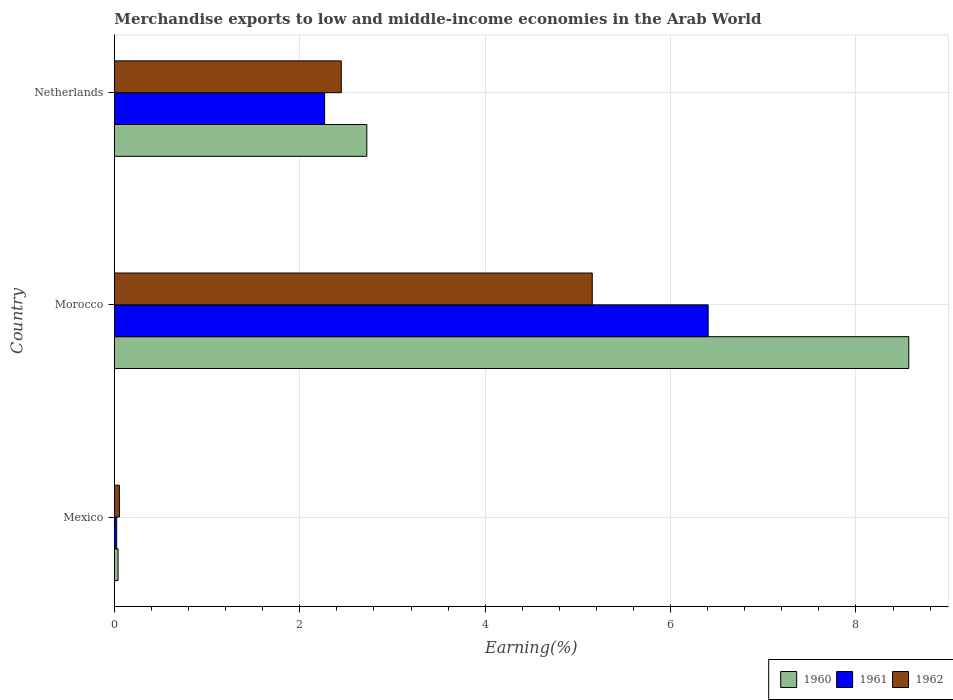How many groups of bars are there?
Your answer should be very brief. 3. Are the number of bars per tick equal to the number of legend labels?
Your answer should be compact. Yes. How many bars are there on the 2nd tick from the top?
Provide a short and direct response. 3. How many bars are there on the 1st tick from the bottom?
Provide a short and direct response. 3. What is the percentage of amount earned from merchandise exports in 1960 in Netherlands?
Offer a terse response. 2.72. Across all countries, what is the maximum percentage of amount earned from merchandise exports in 1961?
Keep it short and to the point. 6.41. Across all countries, what is the minimum percentage of amount earned from merchandise exports in 1960?
Keep it short and to the point. 0.04. In which country was the percentage of amount earned from merchandise exports in 1960 maximum?
Provide a short and direct response. Morocco. What is the total percentage of amount earned from merchandise exports in 1962 in the graph?
Offer a very short reply. 7.66. What is the difference between the percentage of amount earned from merchandise exports in 1962 in Mexico and that in Netherlands?
Make the answer very short. -2.39. What is the difference between the percentage of amount earned from merchandise exports in 1961 in Netherlands and the percentage of amount earned from merchandise exports in 1960 in Mexico?
Your answer should be very brief. 2.23. What is the average percentage of amount earned from merchandise exports in 1960 per country?
Keep it short and to the point. 3.78. What is the difference between the percentage of amount earned from merchandise exports in 1960 and percentage of amount earned from merchandise exports in 1961 in Netherlands?
Make the answer very short. 0.46. What is the ratio of the percentage of amount earned from merchandise exports in 1960 in Mexico to that in Morocco?
Your response must be concise. 0. What is the difference between the highest and the second highest percentage of amount earned from merchandise exports in 1961?
Provide a short and direct response. 4.14. What is the difference between the highest and the lowest percentage of amount earned from merchandise exports in 1961?
Your answer should be very brief. 6.38. In how many countries, is the percentage of amount earned from merchandise exports in 1961 greater than the average percentage of amount earned from merchandise exports in 1961 taken over all countries?
Offer a terse response. 1. Is the sum of the percentage of amount earned from merchandise exports in 1960 in Mexico and Morocco greater than the maximum percentage of amount earned from merchandise exports in 1961 across all countries?
Your answer should be compact. Yes. How many bars are there?
Provide a short and direct response. 9. How many countries are there in the graph?
Your response must be concise. 3. What is the difference between two consecutive major ticks on the X-axis?
Provide a succinct answer. 2. Are the values on the major ticks of X-axis written in scientific E-notation?
Ensure brevity in your answer.  No. Does the graph contain grids?
Ensure brevity in your answer.  Yes. How many legend labels are there?
Provide a short and direct response. 3. What is the title of the graph?
Offer a terse response. Merchandise exports to low and middle-income economies in the Arab World. What is the label or title of the X-axis?
Make the answer very short. Earning(%). What is the label or title of the Y-axis?
Offer a terse response. Country. What is the Earning(%) in 1960 in Mexico?
Offer a terse response. 0.04. What is the Earning(%) in 1961 in Mexico?
Provide a short and direct response. 0.02. What is the Earning(%) in 1962 in Mexico?
Your answer should be compact. 0.05. What is the Earning(%) in 1960 in Morocco?
Your answer should be compact. 8.57. What is the Earning(%) of 1961 in Morocco?
Provide a succinct answer. 6.41. What is the Earning(%) in 1962 in Morocco?
Give a very brief answer. 5.15. What is the Earning(%) of 1960 in Netherlands?
Your answer should be very brief. 2.72. What is the Earning(%) in 1961 in Netherlands?
Provide a short and direct response. 2.27. What is the Earning(%) of 1962 in Netherlands?
Ensure brevity in your answer.  2.45. Across all countries, what is the maximum Earning(%) of 1960?
Offer a very short reply. 8.57. Across all countries, what is the maximum Earning(%) in 1961?
Your answer should be very brief. 6.41. Across all countries, what is the maximum Earning(%) of 1962?
Provide a succinct answer. 5.15. Across all countries, what is the minimum Earning(%) of 1960?
Your answer should be very brief. 0.04. Across all countries, what is the minimum Earning(%) of 1961?
Your response must be concise. 0.02. Across all countries, what is the minimum Earning(%) of 1962?
Keep it short and to the point. 0.05. What is the total Earning(%) in 1960 in the graph?
Provide a short and direct response. 11.33. What is the total Earning(%) in 1961 in the graph?
Your response must be concise. 8.7. What is the total Earning(%) of 1962 in the graph?
Make the answer very short. 7.66. What is the difference between the Earning(%) of 1960 in Mexico and that in Morocco?
Ensure brevity in your answer.  -8.53. What is the difference between the Earning(%) of 1961 in Mexico and that in Morocco?
Keep it short and to the point. -6.38. What is the difference between the Earning(%) in 1962 in Mexico and that in Morocco?
Offer a very short reply. -5.1. What is the difference between the Earning(%) in 1960 in Mexico and that in Netherlands?
Keep it short and to the point. -2.68. What is the difference between the Earning(%) in 1961 in Mexico and that in Netherlands?
Offer a terse response. -2.24. What is the difference between the Earning(%) in 1962 in Mexico and that in Netherlands?
Ensure brevity in your answer.  -2.39. What is the difference between the Earning(%) of 1960 in Morocco and that in Netherlands?
Your answer should be very brief. 5.85. What is the difference between the Earning(%) in 1961 in Morocco and that in Netherlands?
Offer a very short reply. 4.14. What is the difference between the Earning(%) in 1962 in Morocco and that in Netherlands?
Ensure brevity in your answer.  2.71. What is the difference between the Earning(%) in 1960 in Mexico and the Earning(%) in 1961 in Morocco?
Your response must be concise. -6.37. What is the difference between the Earning(%) in 1960 in Mexico and the Earning(%) in 1962 in Morocco?
Your answer should be very brief. -5.12. What is the difference between the Earning(%) of 1961 in Mexico and the Earning(%) of 1962 in Morocco?
Offer a terse response. -5.13. What is the difference between the Earning(%) of 1960 in Mexico and the Earning(%) of 1961 in Netherlands?
Give a very brief answer. -2.23. What is the difference between the Earning(%) of 1960 in Mexico and the Earning(%) of 1962 in Netherlands?
Ensure brevity in your answer.  -2.41. What is the difference between the Earning(%) of 1961 in Mexico and the Earning(%) of 1962 in Netherlands?
Give a very brief answer. -2.42. What is the difference between the Earning(%) in 1960 in Morocco and the Earning(%) in 1961 in Netherlands?
Keep it short and to the point. 6.3. What is the difference between the Earning(%) of 1960 in Morocco and the Earning(%) of 1962 in Netherlands?
Your response must be concise. 6.12. What is the difference between the Earning(%) of 1961 in Morocco and the Earning(%) of 1962 in Netherlands?
Ensure brevity in your answer.  3.96. What is the average Earning(%) of 1960 per country?
Make the answer very short. 3.78. What is the average Earning(%) of 1961 per country?
Ensure brevity in your answer.  2.9. What is the average Earning(%) of 1962 per country?
Your answer should be compact. 2.55. What is the difference between the Earning(%) of 1960 and Earning(%) of 1961 in Mexico?
Your answer should be very brief. 0.01. What is the difference between the Earning(%) in 1960 and Earning(%) in 1962 in Mexico?
Ensure brevity in your answer.  -0.01. What is the difference between the Earning(%) of 1961 and Earning(%) of 1962 in Mexico?
Offer a very short reply. -0.03. What is the difference between the Earning(%) of 1960 and Earning(%) of 1961 in Morocco?
Provide a succinct answer. 2.16. What is the difference between the Earning(%) of 1960 and Earning(%) of 1962 in Morocco?
Give a very brief answer. 3.41. What is the difference between the Earning(%) in 1961 and Earning(%) in 1962 in Morocco?
Your answer should be compact. 1.25. What is the difference between the Earning(%) in 1960 and Earning(%) in 1961 in Netherlands?
Offer a terse response. 0.46. What is the difference between the Earning(%) of 1960 and Earning(%) of 1962 in Netherlands?
Your answer should be compact. 0.28. What is the difference between the Earning(%) of 1961 and Earning(%) of 1962 in Netherlands?
Your answer should be compact. -0.18. What is the ratio of the Earning(%) in 1960 in Mexico to that in Morocco?
Provide a short and direct response. 0. What is the ratio of the Earning(%) of 1961 in Mexico to that in Morocco?
Your answer should be very brief. 0. What is the ratio of the Earning(%) in 1962 in Mexico to that in Morocco?
Ensure brevity in your answer.  0.01. What is the ratio of the Earning(%) of 1960 in Mexico to that in Netherlands?
Your answer should be very brief. 0.01. What is the ratio of the Earning(%) in 1961 in Mexico to that in Netherlands?
Offer a terse response. 0.01. What is the ratio of the Earning(%) in 1962 in Mexico to that in Netherlands?
Offer a very short reply. 0.02. What is the ratio of the Earning(%) in 1960 in Morocco to that in Netherlands?
Offer a very short reply. 3.15. What is the ratio of the Earning(%) of 1961 in Morocco to that in Netherlands?
Provide a short and direct response. 2.82. What is the ratio of the Earning(%) in 1962 in Morocco to that in Netherlands?
Offer a very short reply. 2.11. What is the difference between the highest and the second highest Earning(%) in 1960?
Provide a succinct answer. 5.85. What is the difference between the highest and the second highest Earning(%) in 1961?
Keep it short and to the point. 4.14. What is the difference between the highest and the second highest Earning(%) of 1962?
Your answer should be compact. 2.71. What is the difference between the highest and the lowest Earning(%) in 1960?
Keep it short and to the point. 8.53. What is the difference between the highest and the lowest Earning(%) of 1961?
Keep it short and to the point. 6.38. What is the difference between the highest and the lowest Earning(%) of 1962?
Offer a very short reply. 5.1. 